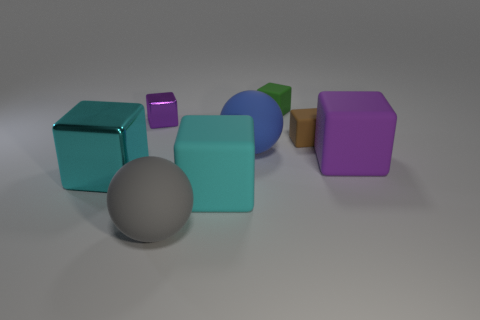Subtract all brown blocks. How many blocks are left? 5 Subtract all purple rubber blocks. How many blocks are left? 5 Subtract all gray blocks. Subtract all yellow cylinders. How many blocks are left? 6 Add 1 small brown blocks. How many objects exist? 9 Subtract all blocks. How many objects are left? 2 Subtract 0 yellow blocks. How many objects are left? 8 Subtract all matte balls. Subtract all small brown rubber things. How many objects are left? 5 Add 2 brown blocks. How many brown blocks are left? 3 Add 1 big purple blocks. How many big purple blocks exist? 2 